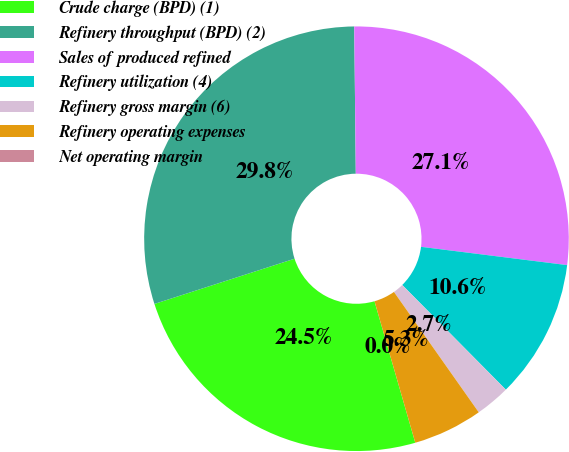Convert chart. <chart><loc_0><loc_0><loc_500><loc_500><pie_chart><fcel>Crude charge (BPD) (1)<fcel>Refinery throughput (BPD) (2)<fcel>Sales of produced refined<fcel>Refinery utilization (4)<fcel>Refinery gross margin (6)<fcel>Refinery operating expenses<fcel>Net operating margin<nl><fcel>24.5%<fcel>29.8%<fcel>27.15%<fcel>10.6%<fcel>2.65%<fcel>5.3%<fcel>0.0%<nl></chart> 